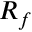<formula> <loc_0><loc_0><loc_500><loc_500>R _ { f }</formula> 